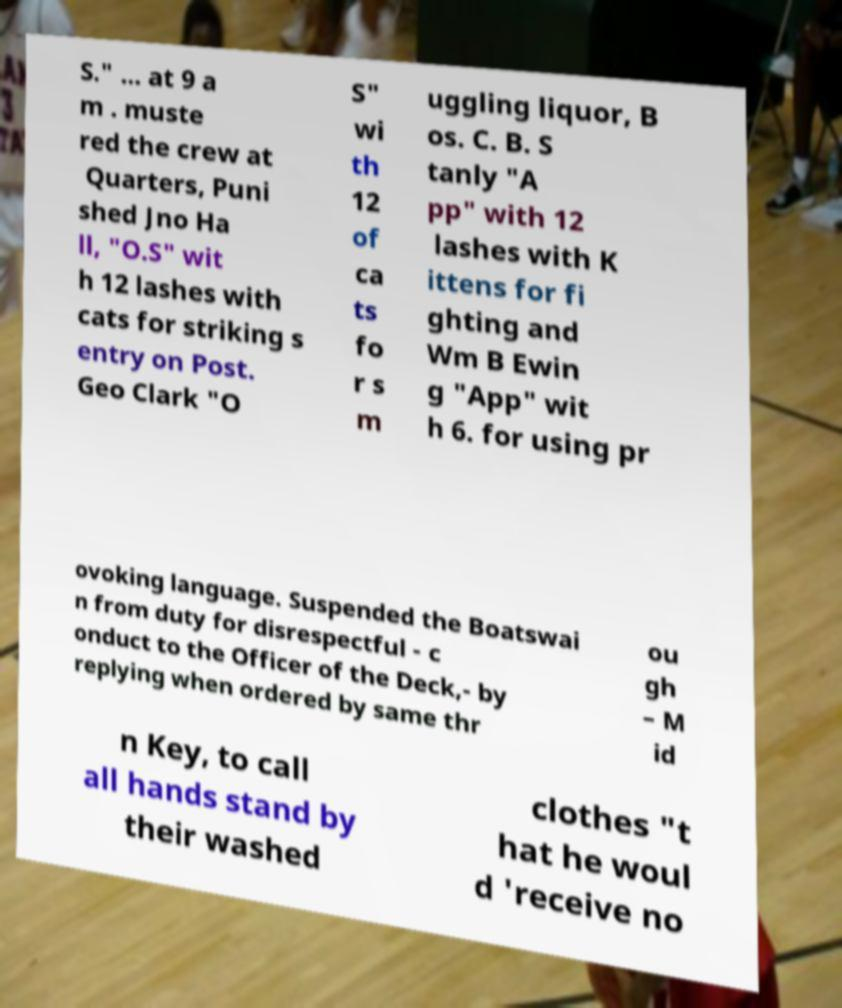What messages or text are displayed in this image? I need them in a readable, typed format. S." ... at 9 a m . muste red the crew at Quarters, Puni shed Jno Ha ll, "O.S" wit h 12 lashes with cats for striking s entry on Post. Geo Clark "O S" wi th 12 of ca ts fo r s m uggling liquor, B os. C. B. S tanly "A pp" with 12 lashes with K ittens for fi ghting and Wm B Ewin g "App" wit h 6. for using pr ovoking language. Suspended the Boatswai n from duty for disrespectful - c onduct to the Officer of the Deck,- by replying when ordered by same thr ou gh – M id n Key, to call all hands stand by their washed clothes "t hat he woul d 'receive no 